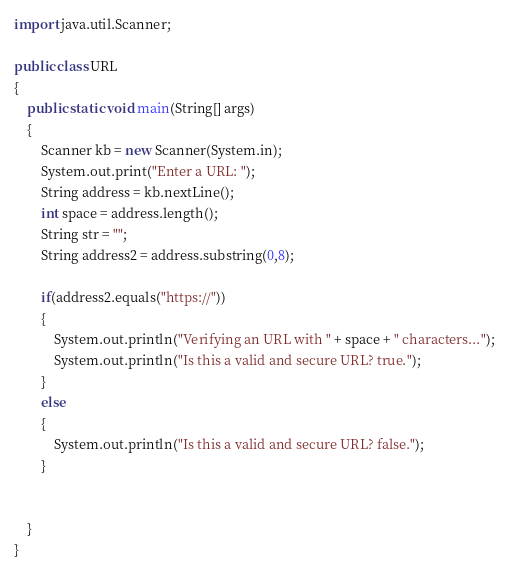Convert code to text. <code><loc_0><loc_0><loc_500><loc_500><_Java_>import java.util.Scanner;

public class URL
{
	public static void main(String[] args)
	{
		Scanner kb = new Scanner(System.in);
		System.out.print("Enter a URL: ");
		String address = kb.nextLine();
		int space = address.length();
		String str = "";
		String address2 = address.substring(0,8);

		if(address2.equals("https://"))
		{
			System.out.println("Verifying an URL with " + space + " characters...");
			System.out.println("Is this a valid and secure URL? true.");
		}
		else
		{
			System.out.println("Is this a valid and secure URL? false.");
		}


	}
}


</code> 